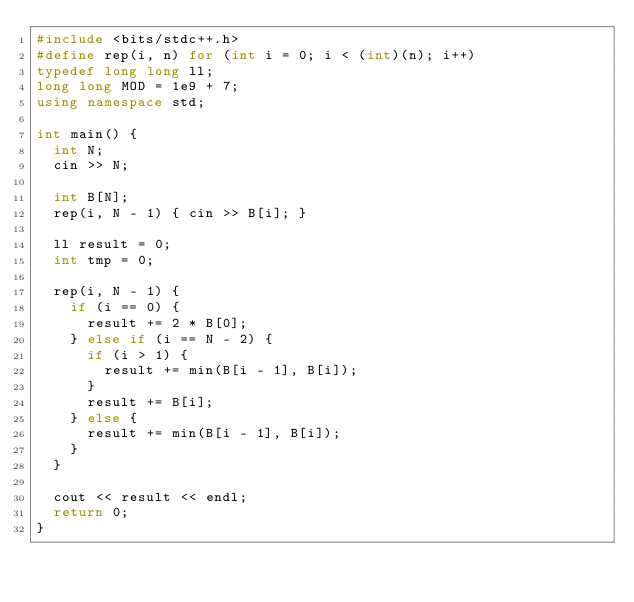<code> <loc_0><loc_0><loc_500><loc_500><_C++_>#include <bits/stdc++.h>
#define rep(i, n) for (int i = 0; i < (int)(n); i++)
typedef long long ll;
long long MOD = 1e9 + 7;
using namespace std;

int main() {
  int N;
  cin >> N;

  int B[N];
  rep(i, N - 1) { cin >> B[i]; }

  ll result = 0;
  int tmp = 0;

  rep(i, N - 1) {
    if (i == 0) {
      result += 2 * B[0];
    } else if (i == N - 2) {
      if (i > 1) {
        result += min(B[i - 1], B[i]);
      }
      result += B[i];
    } else {
      result += min(B[i - 1], B[i]);
    }
  }

  cout << result << endl;
  return 0;
}</code> 